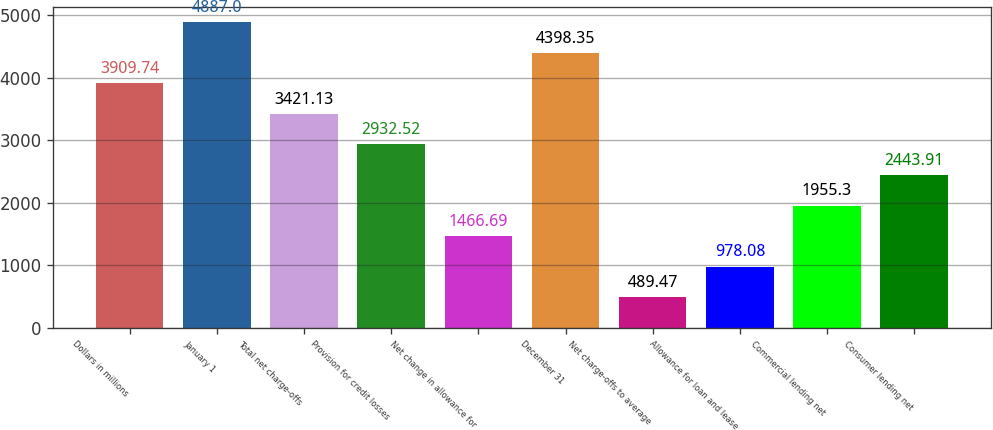Convert chart to OTSL. <chart><loc_0><loc_0><loc_500><loc_500><bar_chart><fcel>Dollars in millions<fcel>January 1<fcel>Total net charge-offs<fcel>Provision for credit losses<fcel>Net change in allowance for<fcel>December 31<fcel>Net charge-offs to average<fcel>Allowance for loan and lease<fcel>Commercial lending net<fcel>Consumer lending net<nl><fcel>3909.74<fcel>4887<fcel>3421.13<fcel>2932.52<fcel>1466.69<fcel>4398.35<fcel>489.47<fcel>978.08<fcel>1955.3<fcel>2443.91<nl></chart> 